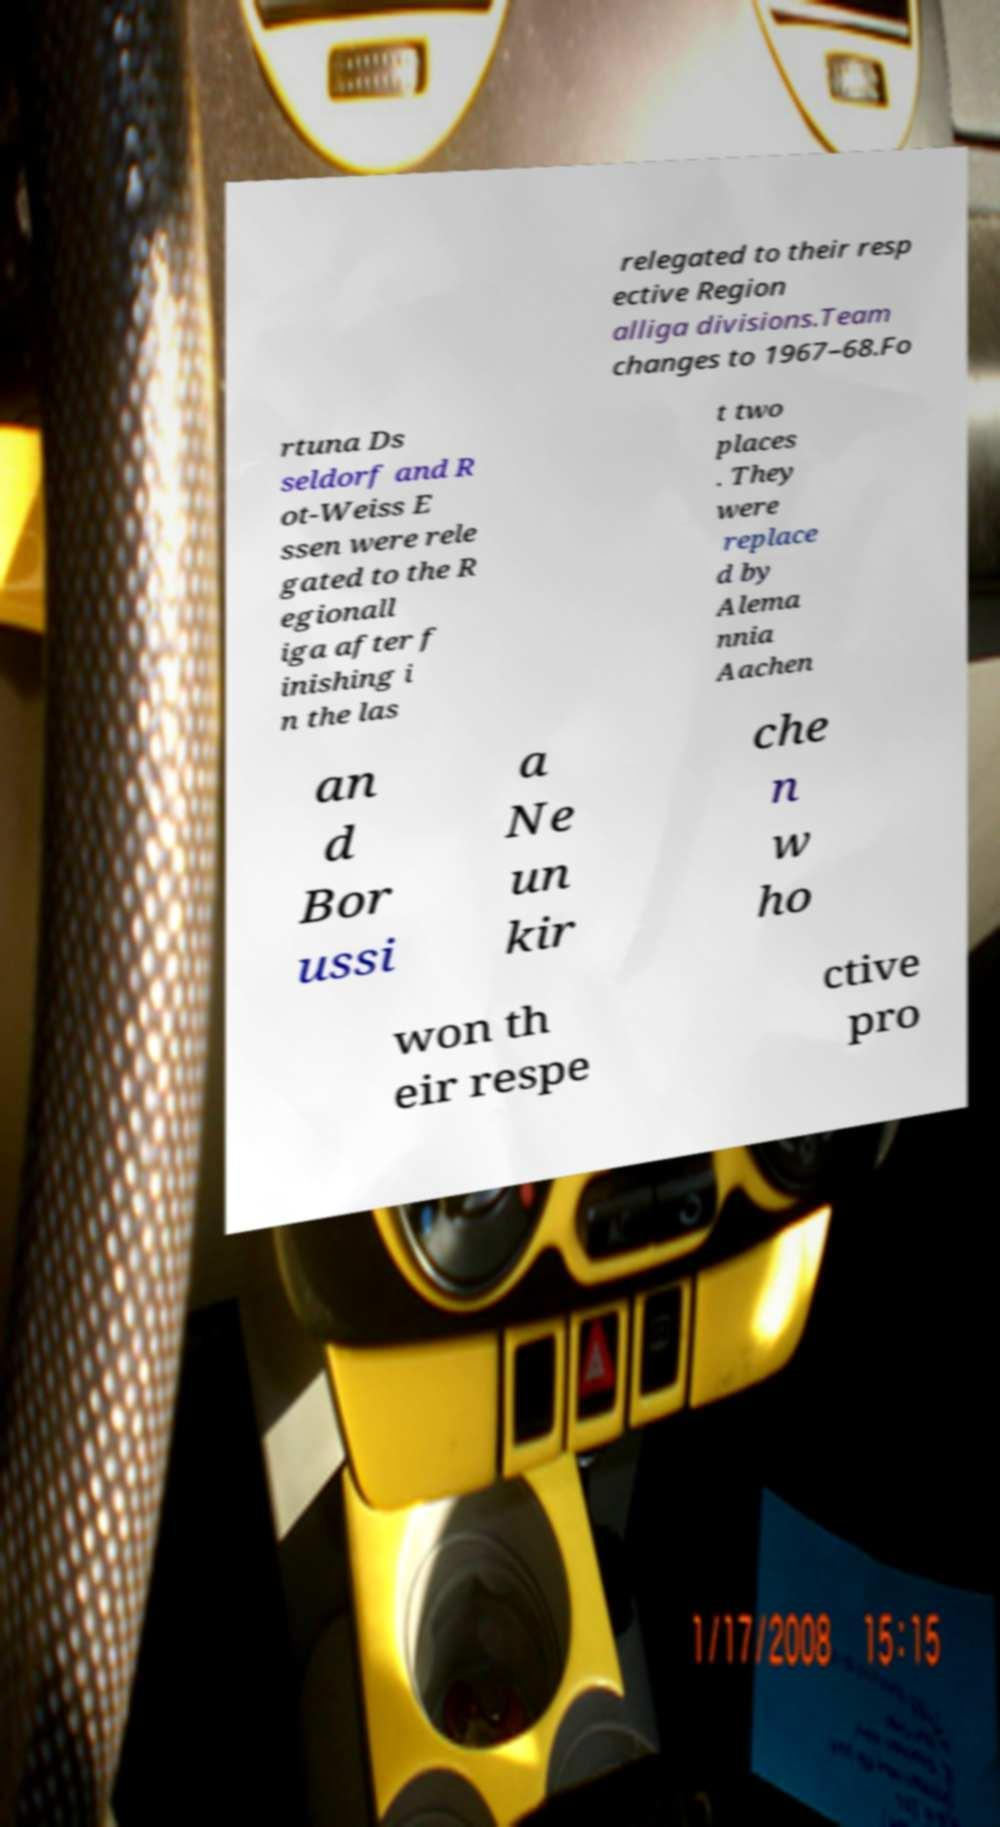For documentation purposes, I need the text within this image transcribed. Could you provide that? relegated to their resp ective Region alliga divisions.Team changes to 1967–68.Fo rtuna Ds seldorf and R ot-Weiss E ssen were rele gated to the R egionall iga after f inishing i n the las t two places . They were replace d by Alema nnia Aachen an d Bor ussi a Ne un kir che n w ho won th eir respe ctive pro 